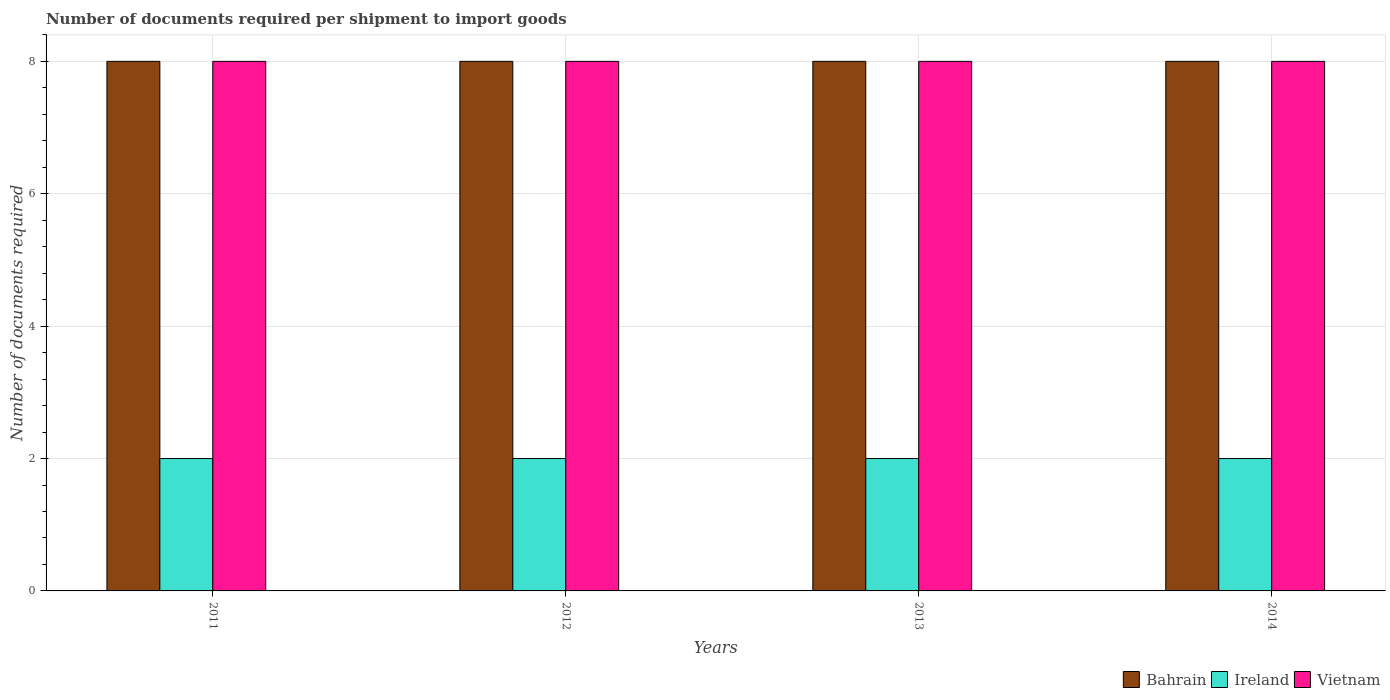How many different coloured bars are there?
Keep it short and to the point. 3. Are the number of bars per tick equal to the number of legend labels?
Ensure brevity in your answer.  Yes. How many bars are there on the 2nd tick from the left?
Ensure brevity in your answer.  3. How many bars are there on the 2nd tick from the right?
Make the answer very short. 3. What is the number of documents required per shipment to import goods in Vietnam in 2012?
Your response must be concise. 8. Across all years, what is the maximum number of documents required per shipment to import goods in Ireland?
Your answer should be compact. 2. Across all years, what is the minimum number of documents required per shipment to import goods in Ireland?
Ensure brevity in your answer.  2. In which year was the number of documents required per shipment to import goods in Bahrain minimum?
Make the answer very short. 2011. What is the total number of documents required per shipment to import goods in Ireland in the graph?
Offer a very short reply. 8. What is the difference between the number of documents required per shipment to import goods in Vietnam in 2012 and that in 2013?
Your answer should be compact. 0. What is the average number of documents required per shipment to import goods in Vietnam per year?
Your response must be concise. 8. In the year 2013, what is the difference between the number of documents required per shipment to import goods in Ireland and number of documents required per shipment to import goods in Bahrain?
Keep it short and to the point. -6. What is the ratio of the number of documents required per shipment to import goods in Vietnam in 2012 to that in 2014?
Provide a short and direct response. 1. Is the number of documents required per shipment to import goods in Bahrain in 2011 less than that in 2013?
Keep it short and to the point. No. Is the difference between the number of documents required per shipment to import goods in Ireland in 2011 and 2012 greater than the difference between the number of documents required per shipment to import goods in Bahrain in 2011 and 2012?
Offer a very short reply. No. What is the difference between the highest and the second highest number of documents required per shipment to import goods in Ireland?
Your answer should be compact. 0. What is the difference between the highest and the lowest number of documents required per shipment to import goods in Vietnam?
Make the answer very short. 0. In how many years, is the number of documents required per shipment to import goods in Bahrain greater than the average number of documents required per shipment to import goods in Bahrain taken over all years?
Your response must be concise. 0. Is the sum of the number of documents required per shipment to import goods in Bahrain in 2011 and 2012 greater than the maximum number of documents required per shipment to import goods in Vietnam across all years?
Your answer should be very brief. Yes. What does the 2nd bar from the left in 2014 represents?
Offer a very short reply. Ireland. What does the 1st bar from the right in 2013 represents?
Provide a succinct answer. Vietnam. Is it the case that in every year, the sum of the number of documents required per shipment to import goods in Ireland and number of documents required per shipment to import goods in Vietnam is greater than the number of documents required per shipment to import goods in Bahrain?
Provide a succinct answer. Yes. How many years are there in the graph?
Offer a very short reply. 4. What is the difference between two consecutive major ticks on the Y-axis?
Offer a very short reply. 2. Are the values on the major ticks of Y-axis written in scientific E-notation?
Your response must be concise. No. Does the graph contain any zero values?
Provide a short and direct response. No. Does the graph contain grids?
Your response must be concise. Yes. Where does the legend appear in the graph?
Your answer should be compact. Bottom right. How many legend labels are there?
Provide a succinct answer. 3. How are the legend labels stacked?
Offer a terse response. Horizontal. What is the title of the graph?
Make the answer very short. Number of documents required per shipment to import goods. Does "Mali" appear as one of the legend labels in the graph?
Offer a terse response. No. What is the label or title of the X-axis?
Ensure brevity in your answer.  Years. What is the label or title of the Y-axis?
Ensure brevity in your answer.  Number of documents required. What is the Number of documents required in Bahrain in 2012?
Your answer should be very brief. 8. What is the Number of documents required in Ireland in 2012?
Ensure brevity in your answer.  2. What is the Number of documents required of Bahrain in 2013?
Your answer should be very brief. 8. What is the Number of documents required in Vietnam in 2013?
Your answer should be very brief. 8. What is the Number of documents required of Ireland in 2014?
Ensure brevity in your answer.  2. What is the Number of documents required in Vietnam in 2014?
Your answer should be compact. 8. Across all years, what is the maximum Number of documents required in Vietnam?
Your answer should be compact. 8. Across all years, what is the minimum Number of documents required of Ireland?
Make the answer very short. 2. What is the total Number of documents required in Bahrain in the graph?
Ensure brevity in your answer.  32. What is the difference between the Number of documents required in Bahrain in 2011 and that in 2012?
Make the answer very short. 0. What is the difference between the Number of documents required of Bahrain in 2011 and that in 2013?
Offer a terse response. 0. What is the difference between the Number of documents required in Ireland in 2011 and that in 2013?
Provide a short and direct response. 0. What is the difference between the Number of documents required in Ireland in 2011 and that in 2014?
Your answer should be compact. 0. What is the difference between the Number of documents required of Vietnam in 2011 and that in 2014?
Your answer should be very brief. 0. What is the difference between the Number of documents required in Bahrain in 2012 and that in 2013?
Offer a terse response. 0. What is the difference between the Number of documents required in Vietnam in 2012 and that in 2013?
Ensure brevity in your answer.  0. What is the difference between the Number of documents required in Ireland in 2012 and that in 2014?
Offer a terse response. 0. What is the difference between the Number of documents required in Vietnam in 2012 and that in 2014?
Keep it short and to the point. 0. What is the difference between the Number of documents required of Bahrain in 2013 and that in 2014?
Give a very brief answer. 0. What is the difference between the Number of documents required in Vietnam in 2013 and that in 2014?
Make the answer very short. 0. What is the difference between the Number of documents required in Bahrain in 2011 and the Number of documents required in Ireland in 2012?
Provide a short and direct response. 6. What is the difference between the Number of documents required in Bahrain in 2011 and the Number of documents required in Vietnam in 2012?
Provide a succinct answer. 0. What is the difference between the Number of documents required in Ireland in 2011 and the Number of documents required in Vietnam in 2012?
Your response must be concise. -6. What is the difference between the Number of documents required of Bahrain in 2011 and the Number of documents required of Ireland in 2014?
Give a very brief answer. 6. What is the difference between the Number of documents required of Ireland in 2011 and the Number of documents required of Vietnam in 2014?
Ensure brevity in your answer.  -6. What is the difference between the Number of documents required of Bahrain in 2012 and the Number of documents required of Vietnam in 2013?
Offer a very short reply. 0. What is the difference between the Number of documents required of Ireland in 2012 and the Number of documents required of Vietnam in 2014?
Offer a terse response. -6. What is the difference between the Number of documents required of Bahrain in 2013 and the Number of documents required of Ireland in 2014?
Your answer should be compact. 6. What is the average Number of documents required in Bahrain per year?
Offer a terse response. 8. In the year 2011, what is the difference between the Number of documents required of Bahrain and Number of documents required of Vietnam?
Give a very brief answer. 0. In the year 2012, what is the difference between the Number of documents required of Bahrain and Number of documents required of Ireland?
Your answer should be very brief. 6. In the year 2013, what is the difference between the Number of documents required of Bahrain and Number of documents required of Ireland?
Your answer should be compact. 6. In the year 2013, what is the difference between the Number of documents required in Ireland and Number of documents required in Vietnam?
Your answer should be compact. -6. In the year 2014, what is the difference between the Number of documents required in Bahrain and Number of documents required in Ireland?
Your answer should be compact. 6. In the year 2014, what is the difference between the Number of documents required of Bahrain and Number of documents required of Vietnam?
Your response must be concise. 0. In the year 2014, what is the difference between the Number of documents required in Ireland and Number of documents required in Vietnam?
Provide a succinct answer. -6. What is the ratio of the Number of documents required of Vietnam in 2011 to that in 2012?
Your response must be concise. 1. What is the ratio of the Number of documents required of Vietnam in 2011 to that in 2013?
Ensure brevity in your answer.  1. What is the ratio of the Number of documents required in Ireland in 2011 to that in 2014?
Your response must be concise. 1. What is the ratio of the Number of documents required of Bahrain in 2012 to that in 2013?
Offer a terse response. 1. What is the ratio of the Number of documents required in Ireland in 2012 to that in 2013?
Your answer should be compact. 1. What is the ratio of the Number of documents required of Vietnam in 2012 to that in 2013?
Your answer should be very brief. 1. What is the ratio of the Number of documents required in Ireland in 2012 to that in 2014?
Provide a short and direct response. 1. What is the ratio of the Number of documents required of Vietnam in 2012 to that in 2014?
Ensure brevity in your answer.  1. What is the ratio of the Number of documents required of Bahrain in 2013 to that in 2014?
Provide a succinct answer. 1. What is the difference between the highest and the second highest Number of documents required of Bahrain?
Your answer should be very brief. 0. What is the difference between the highest and the second highest Number of documents required in Ireland?
Your answer should be compact. 0. 